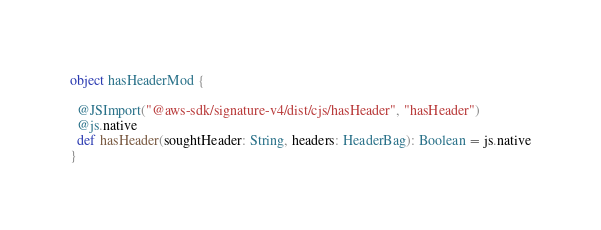Convert code to text. <code><loc_0><loc_0><loc_500><loc_500><_Scala_>object hasHeaderMod {
  
  @JSImport("@aws-sdk/signature-v4/dist/cjs/hasHeader", "hasHeader")
  @js.native
  def hasHeader(soughtHeader: String, headers: HeaderBag): Boolean = js.native
}
</code> 